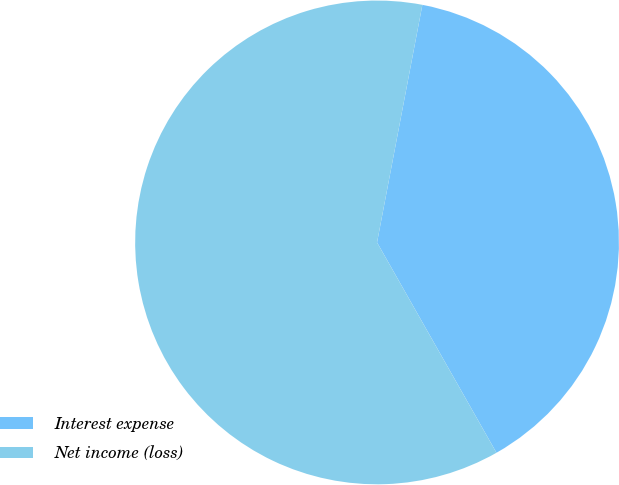Convert chart to OTSL. <chart><loc_0><loc_0><loc_500><loc_500><pie_chart><fcel>Interest expense<fcel>Net income (loss)<nl><fcel>38.78%<fcel>61.22%<nl></chart> 